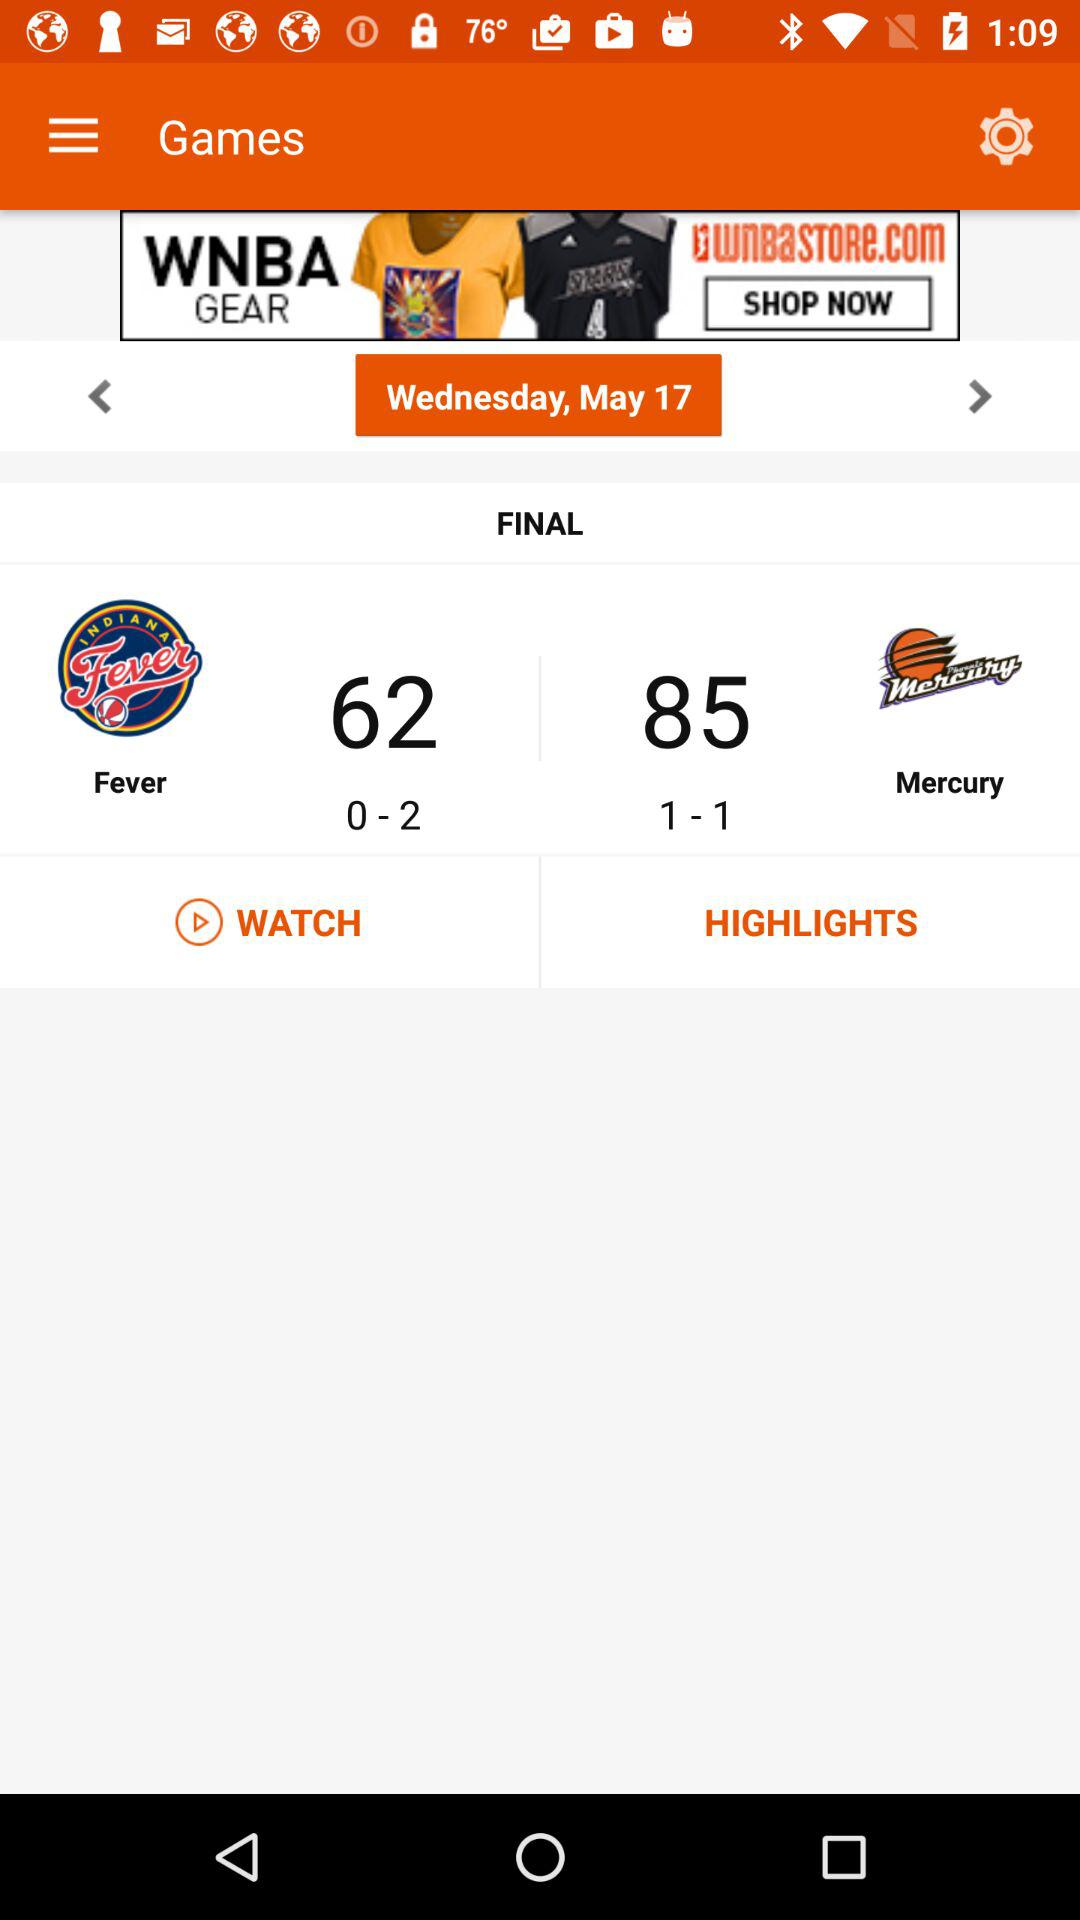What is the team's name? The team's names are "Fever" and "Mercury". 